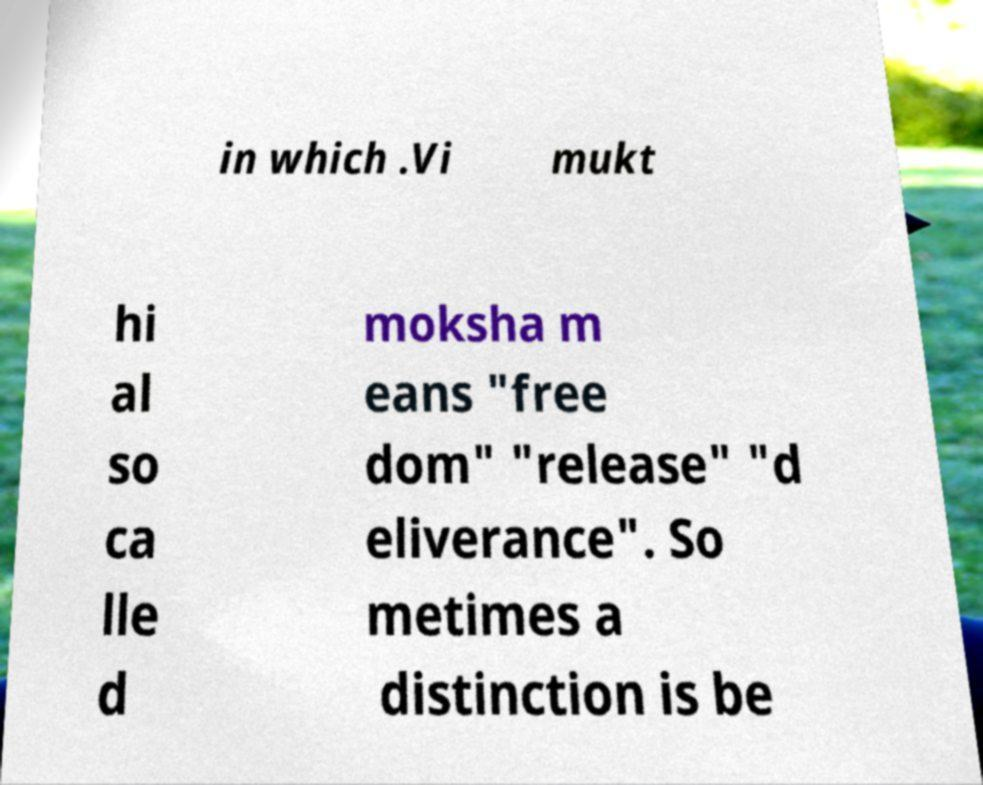Please read and relay the text visible in this image. What does it say? in which .Vi mukt hi al so ca lle d moksha m eans "free dom" "release" "d eliverance". So metimes a distinction is be 